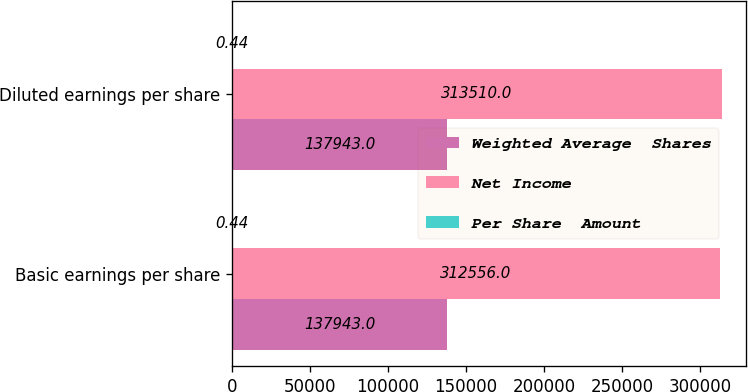Convert chart to OTSL. <chart><loc_0><loc_0><loc_500><loc_500><stacked_bar_chart><ecel><fcel>Basic earnings per share<fcel>Diluted earnings per share<nl><fcel>Weighted Average  Shares<fcel>137943<fcel>137943<nl><fcel>Net Income<fcel>312556<fcel>313510<nl><fcel>Per Share  Amount<fcel>0.44<fcel>0.44<nl></chart> 